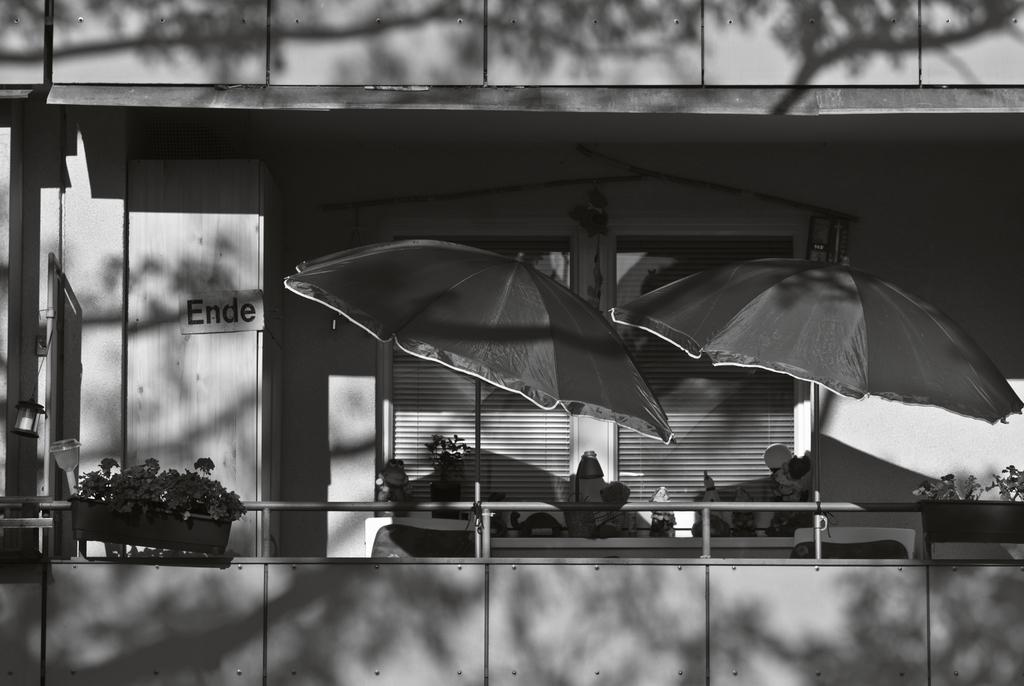What is the color scheme of the image? The image is black and white. What can be seen on the balcony in the image? There are two umbrellas and plants on the balcony. What is visible in the background of the image? There is a wall with a window in the background. How many noses can be seen on the crow in the image? There is no crow or nose present in the image. What is the duration of the minute shown in the image? There is no specific duration or time measurement shown in the image. 